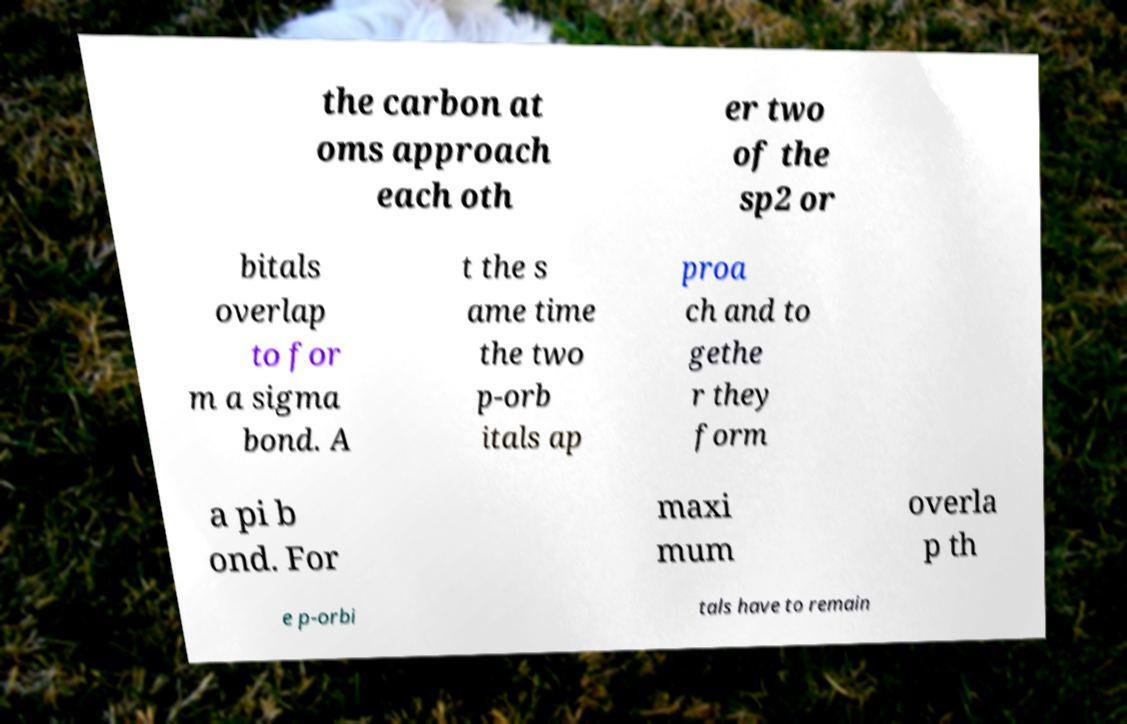For documentation purposes, I need the text within this image transcribed. Could you provide that? the carbon at oms approach each oth er two of the sp2 or bitals overlap to for m a sigma bond. A t the s ame time the two p-orb itals ap proa ch and to gethe r they form a pi b ond. For maxi mum overla p th e p-orbi tals have to remain 